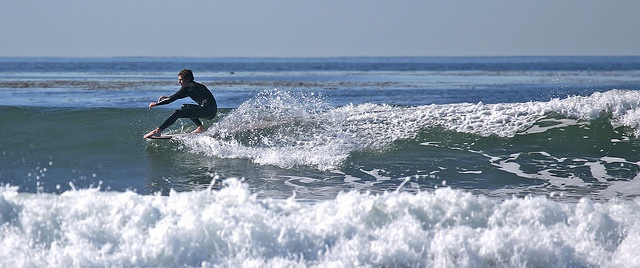Describe the objects in this image and their specific colors. I can see people in darkgray, black, and gray tones and surfboard in darkgray, lightgray, black, and gray tones in this image. 